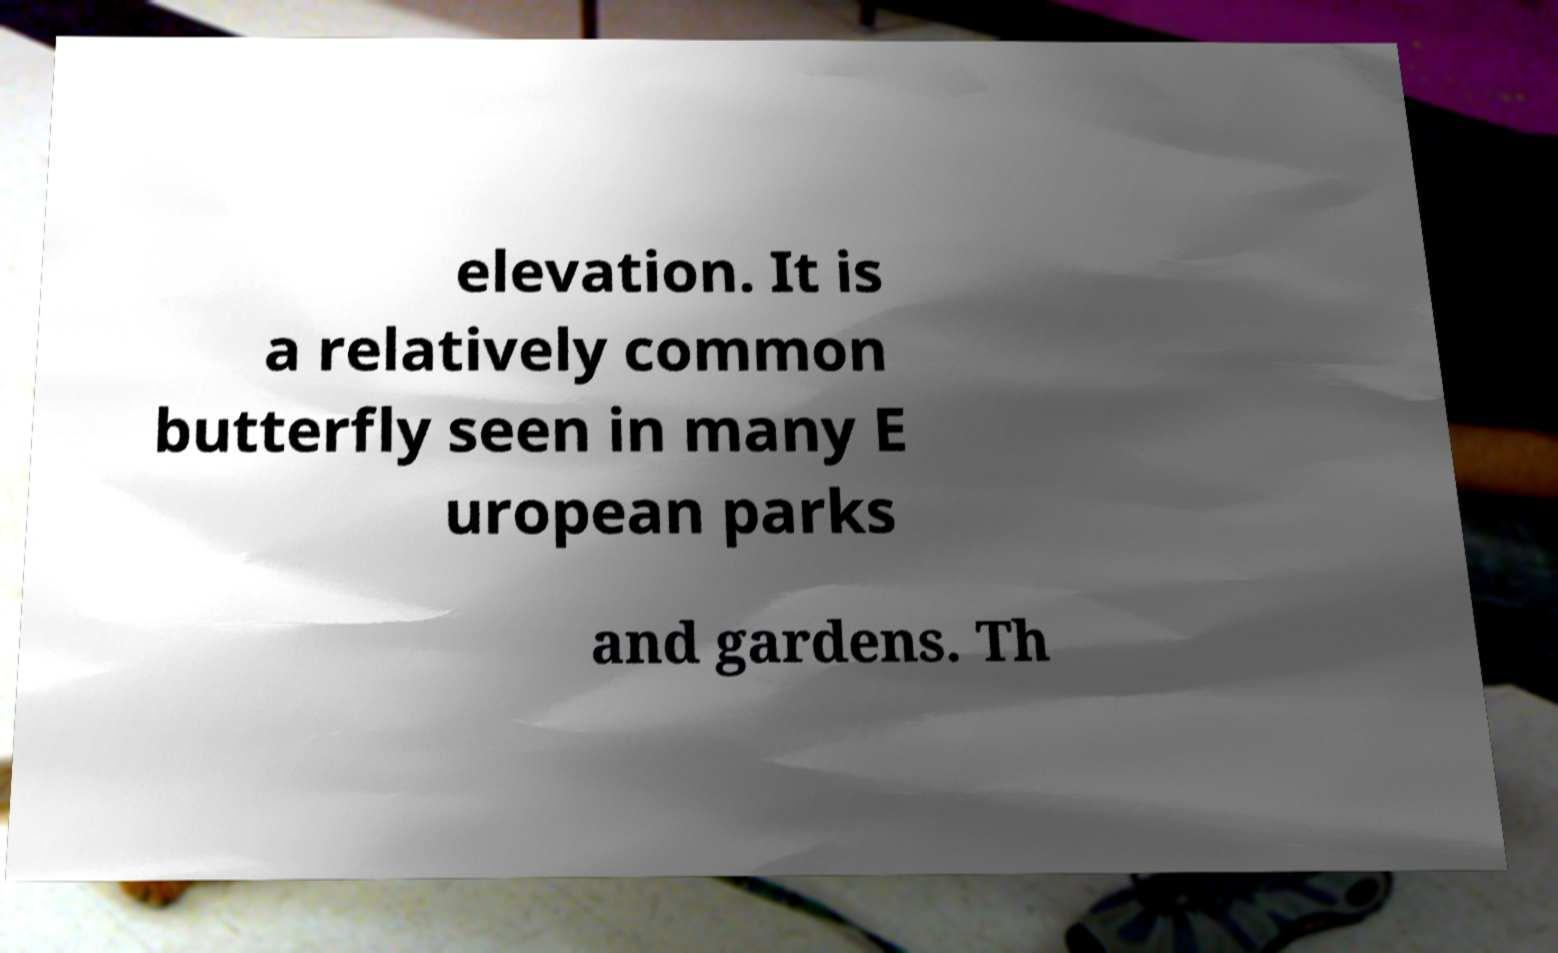Could you extract and type out the text from this image? elevation. It is a relatively common butterfly seen in many E uropean parks and gardens. Th 